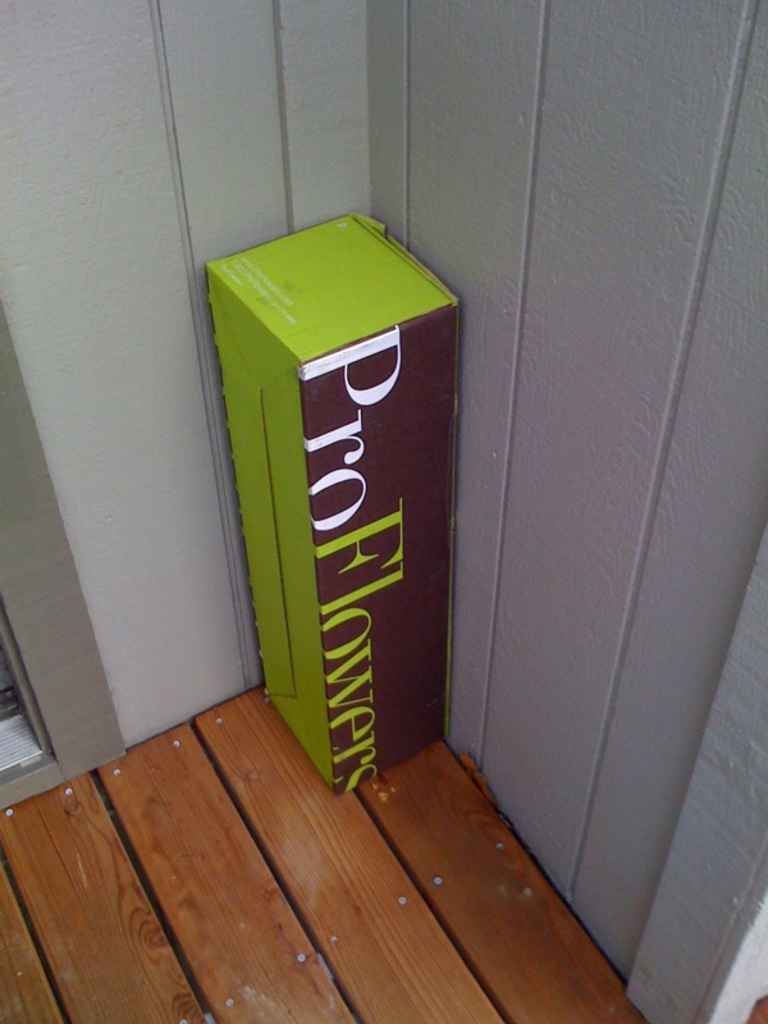Can you tell me about the possible reason for its placement on the deck? The box is strategically placed on the deck, likely because it’s a secure and visible spot for deliveries. Placing the box here minimizes the risk of damage from ground moisture and keeps it away from direct sidewalk traffic which could potentially lead to theft or disruption. It is also a commonly accessible area where the recipient can easily see and retrieve the delivery. What does the positioning of the box against the wall imply? The positioning of the box leaning against the wall implies a careful delivery. The delivery person likely chose this arrangement to ensure the box remains upright and stable, reducing the risk of tipping over and potentially damaging its contents. It demonstrates a thoughtful consideration of preserving the condition of what’s inside, particularly if the contents are delicate like flowers. 